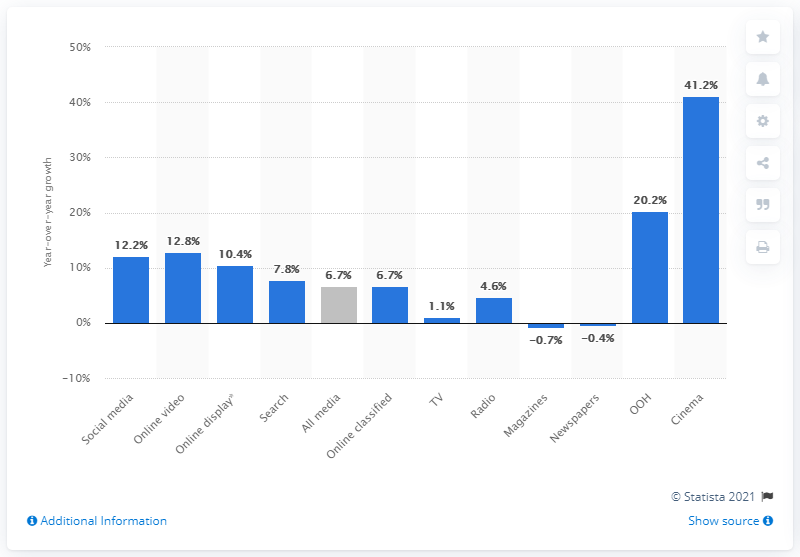Outline some significant characteristics in this image. According to projections, magazines and newspapers are expected to experience a significant decline in growth in 2021, with negative percentages anticipated in the range of 41.2%. Cinema advertising investments are projected to increase by 41.2% in 2021, indicating a strong demand for this form of advertising. The projected growth for Out of Home (OOH) ad spend in 2021 is expected to be 20.2%. 